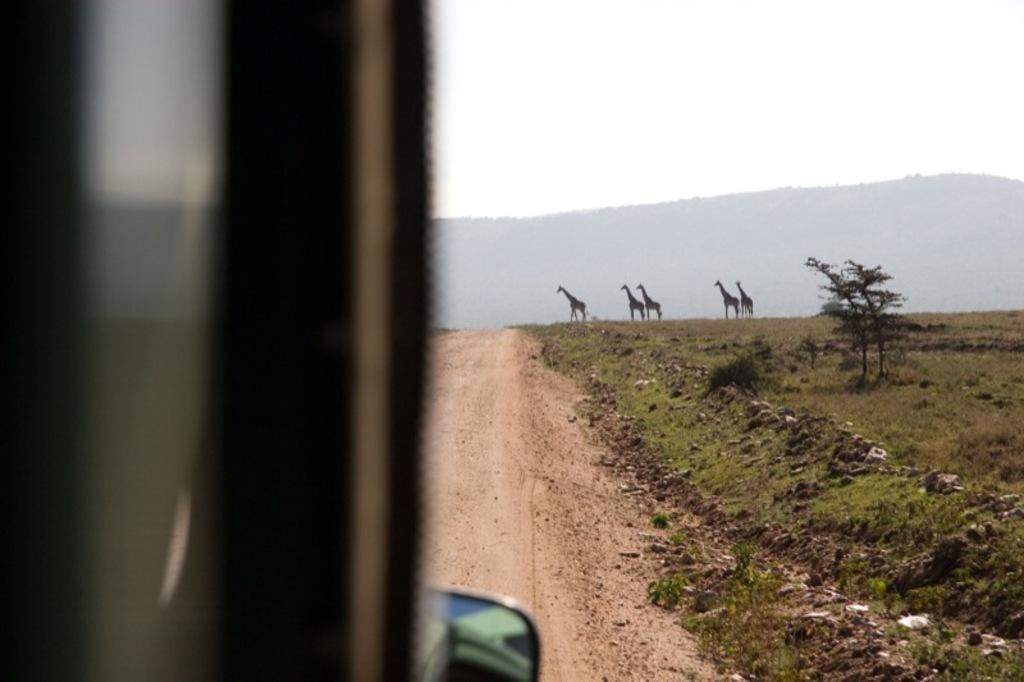Describe this image in one or two sentences. In this image we can see grass, plants, ground, and giraffes. In the background we can see mountain and sky. On the left side of the image we can see a vehicle which is truncated. 